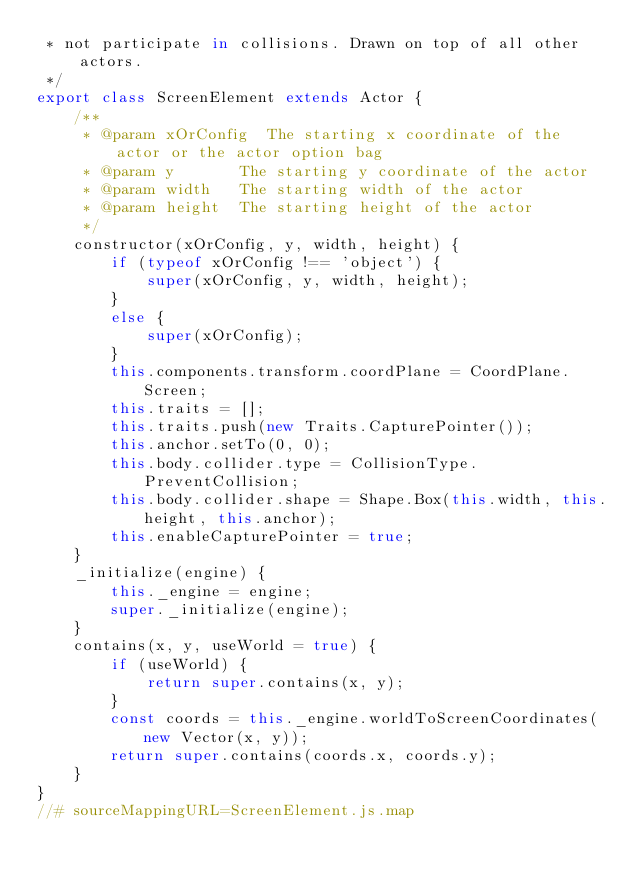<code> <loc_0><loc_0><loc_500><loc_500><_JavaScript_> * not participate in collisions. Drawn on top of all other actors.
 */
export class ScreenElement extends Actor {
    /**
     * @param xOrConfig  The starting x coordinate of the actor or the actor option bag
     * @param y       The starting y coordinate of the actor
     * @param width   The starting width of the actor
     * @param height  The starting height of the actor
     */
    constructor(xOrConfig, y, width, height) {
        if (typeof xOrConfig !== 'object') {
            super(xOrConfig, y, width, height);
        }
        else {
            super(xOrConfig);
        }
        this.components.transform.coordPlane = CoordPlane.Screen;
        this.traits = [];
        this.traits.push(new Traits.CapturePointer());
        this.anchor.setTo(0, 0);
        this.body.collider.type = CollisionType.PreventCollision;
        this.body.collider.shape = Shape.Box(this.width, this.height, this.anchor);
        this.enableCapturePointer = true;
    }
    _initialize(engine) {
        this._engine = engine;
        super._initialize(engine);
    }
    contains(x, y, useWorld = true) {
        if (useWorld) {
            return super.contains(x, y);
        }
        const coords = this._engine.worldToScreenCoordinates(new Vector(x, y));
        return super.contains(coords.x, coords.y);
    }
}
//# sourceMappingURL=ScreenElement.js.map</code> 